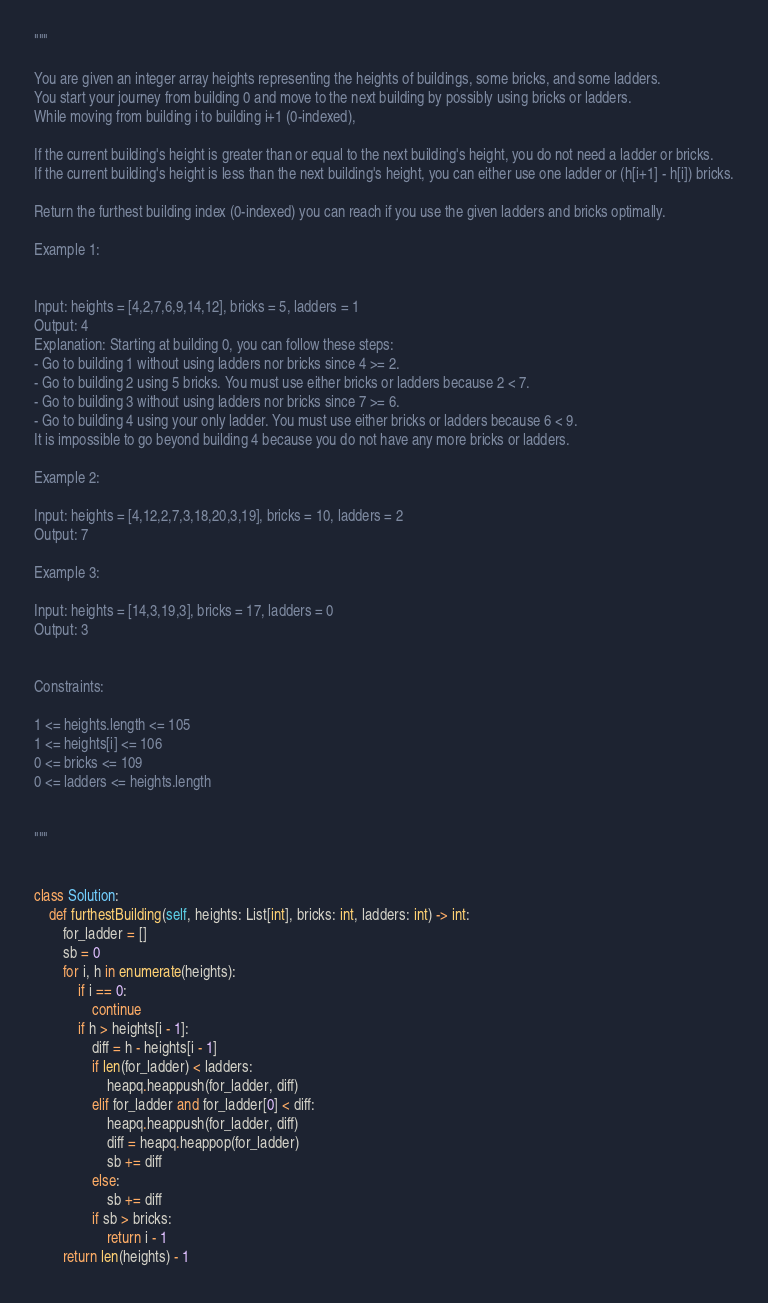<code> <loc_0><loc_0><loc_500><loc_500><_Python_>"""

You are given an integer array heights representing the heights of buildings, some bricks, and some ladders.
You start your journey from building 0 and move to the next building by possibly using bricks or ladders.
While moving from building i to building i+1 (0-indexed),

If the current building's height is greater than or equal to the next building's height, you do not need a ladder or bricks.
If the current building's height is less than the next building's height, you can either use one ladder or (h[i+1] - h[i]) bricks.

Return the furthest building index (0-indexed) you can reach if you use the given ladders and bricks optimally.
 
Example 1:


Input: heights = [4,2,7,6,9,14,12], bricks = 5, ladders = 1
Output: 4
Explanation: Starting at building 0, you can follow these steps:
- Go to building 1 without using ladders nor bricks since 4 >= 2.
- Go to building 2 using 5 bricks. You must use either bricks or ladders because 2 < 7.
- Go to building 3 without using ladders nor bricks since 7 >= 6.
- Go to building 4 using your only ladder. You must use either bricks or ladders because 6 < 9.
It is impossible to go beyond building 4 because you do not have any more bricks or ladders.

Example 2:

Input: heights = [4,12,2,7,3,18,20,3,19], bricks = 10, ladders = 2
Output: 7

Example 3:

Input: heights = [14,3,19,3], bricks = 17, ladders = 0
Output: 3

 
Constraints:

1 <= heights.length <= 105
1 <= heights[i] <= 106
0 <= bricks <= 109
0 <= ladders <= heights.length


"""


class Solution:
    def furthestBuilding(self, heights: List[int], bricks: int, ladders: int) -> int:
        for_ladder = []
        sb = 0
        for i, h in enumerate(heights):
            if i == 0:
                continue
            if h > heights[i - 1]:
                diff = h - heights[i - 1]
                if len(for_ladder) < ladders:
                    heapq.heappush(for_ladder, diff)
                elif for_ladder and for_ladder[0] < diff:
                    heapq.heappush(for_ladder, diff)
                    diff = heapq.heappop(for_ladder)
                    sb += diff
                else:
                    sb += diff
                if sb > bricks:
                    return i - 1
        return len(heights) - 1</code> 